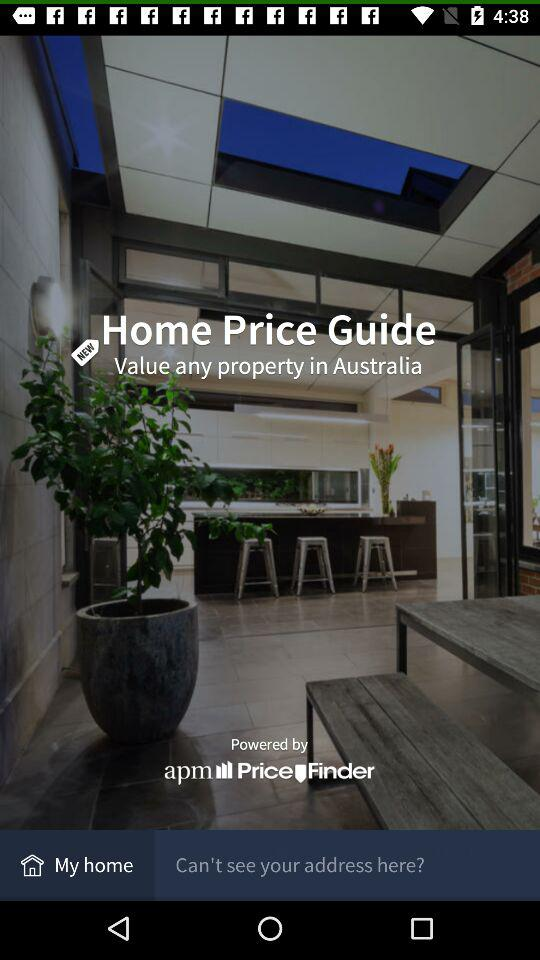Who created the application?
When the provided information is insufficient, respond with <no answer>. <no answer> 